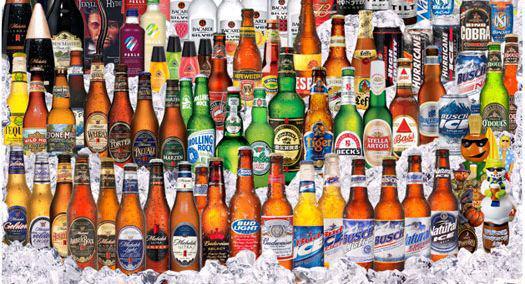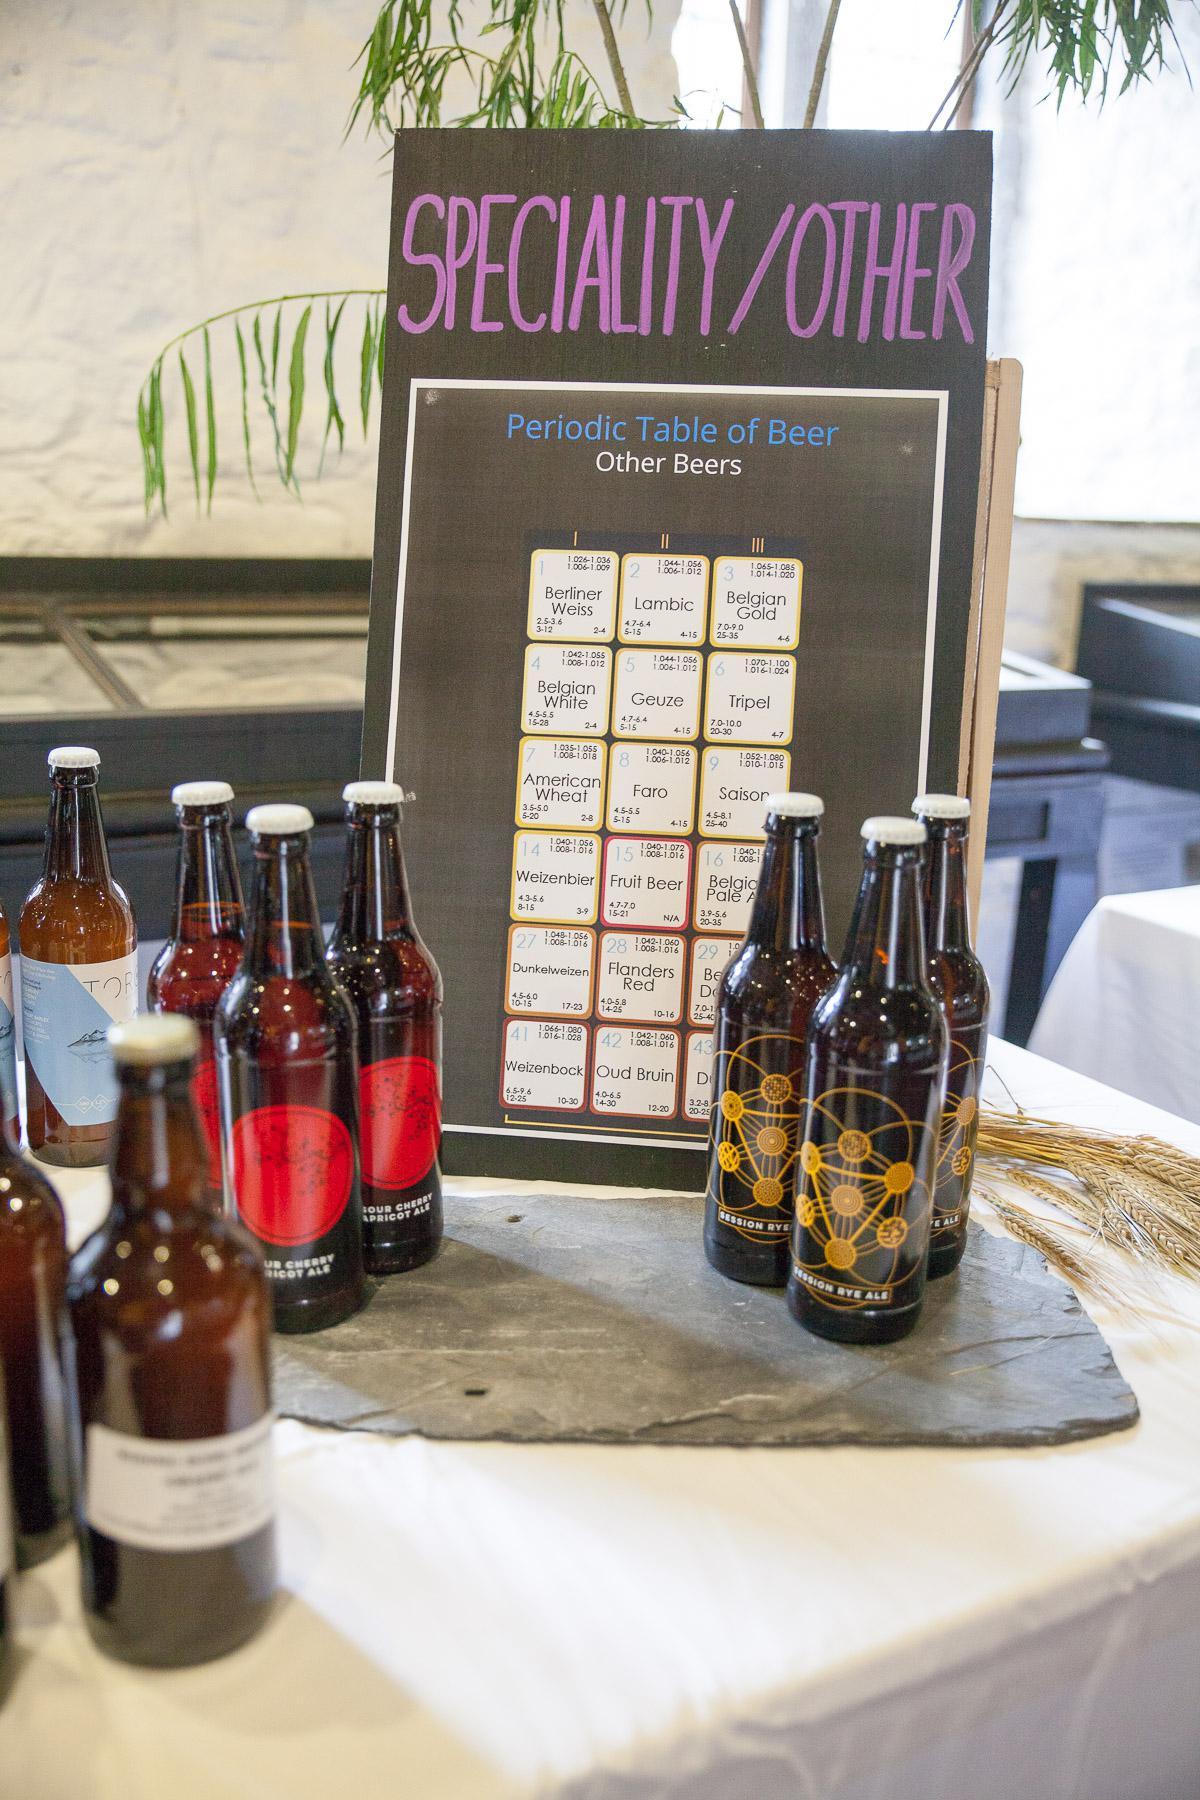The first image is the image on the left, the second image is the image on the right. Evaluate the accuracy of this statement regarding the images: "In at least one image there are four rows of beer.". Is it true? Answer yes or no. Yes. The first image is the image on the left, the second image is the image on the right. Given the left and right images, does the statement "The left image contains at least three times as many bottles as the right image, and the bottles in the right image are displayed on a visible flat surface." hold true? Answer yes or no. Yes. 